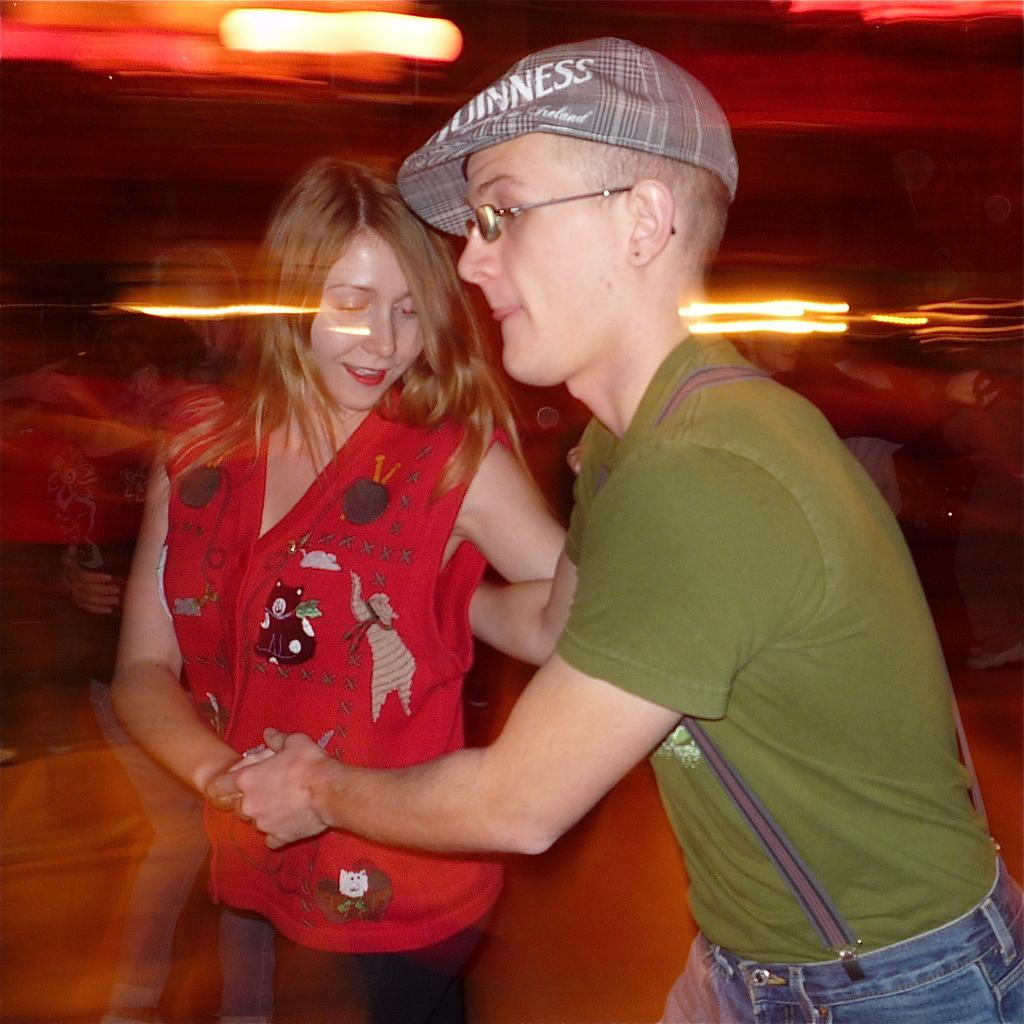How many people are in the image? There are two persons in the image. Can you describe the background of the image? The background of the image is blurred. What type of hose is the queen using in the image? There is no queen or hose present in the image. 